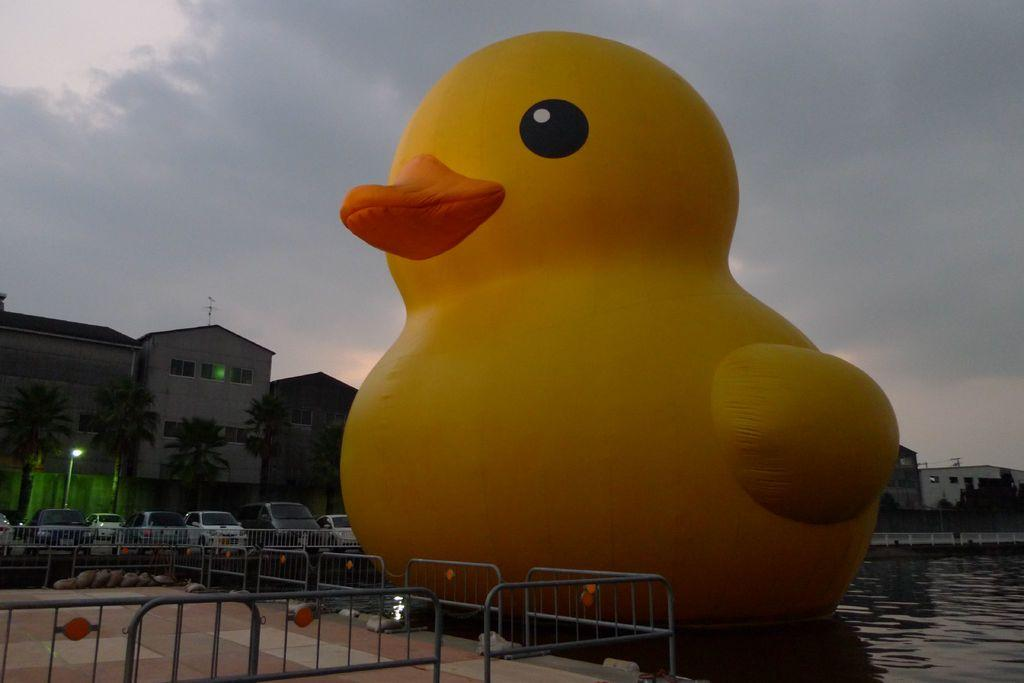What type of animal is in the image? There is a duck in the image. What color is the duck? The duck is yellow. What is at the bottom of the image? There is water at the bottom of the image. What is to the left of the image? There is a fencing to the left of the image. What can be seen in the background of the image? There are cars and buildings in the background of the image. Can you tell me who won the argument between the lock and the toad in the image? There is no lock or toad present in the image, and therefore no such argument can be observed. 